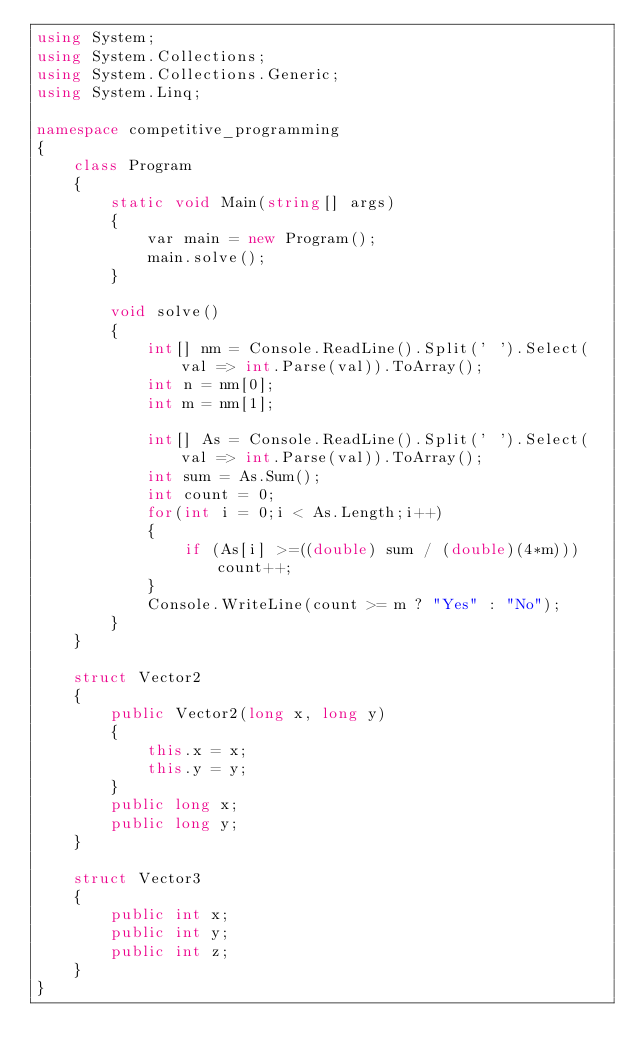Convert code to text. <code><loc_0><loc_0><loc_500><loc_500><_C#_>using System;
using System.Collections;
using System.Collections.Generic;
using System.Linq;

namespace competitive_programming
{
    class Program
    {
        static void Main(string[] args)
        {
            var main = new Program();
            main.solve();
        }

        void solve()
        {
            int[] nm = Console.ReadLine().Split(' ').Select(val => int.Parse(val)).ToArray();
            int n = nm[0];
            int m = nm[1];

            int[] As = Console.ReadLine().Split(' ').Select(val => int.Parse(val)).ToArray();
            int sum = As.Sum();
            int count = 0;
            for(int i = 0;i < As.Length;i++)
            {
                if (As[i] >=((double) sum / (double)(4*m))) count++;
            }
            Console.WriteLine(count >= m ? "Yes" : "No");
        }
    }

    struct Vector2
    {
        public Vector2(long x, long y)
        {
            this.x = x;
            this.y = y;
        }
        public long x;
        public long y;
    }

    struct Vector3
    {
        public int x;
        public int y;
        public int z;
    }
}
</code> 